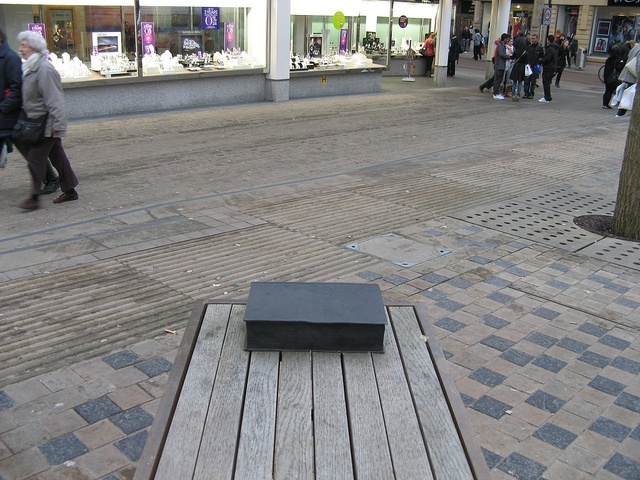Describe the objects in this image and their specific colors. I can see bench in white, darkgray, gray, and black tones, book in white, gray, black, and darkgray tones, people in white, black, gray, and darkgray tones, people in white, black, gray, and darkblue tones, and people in white, black, gray, maroon, and darkgray tones in this image. 